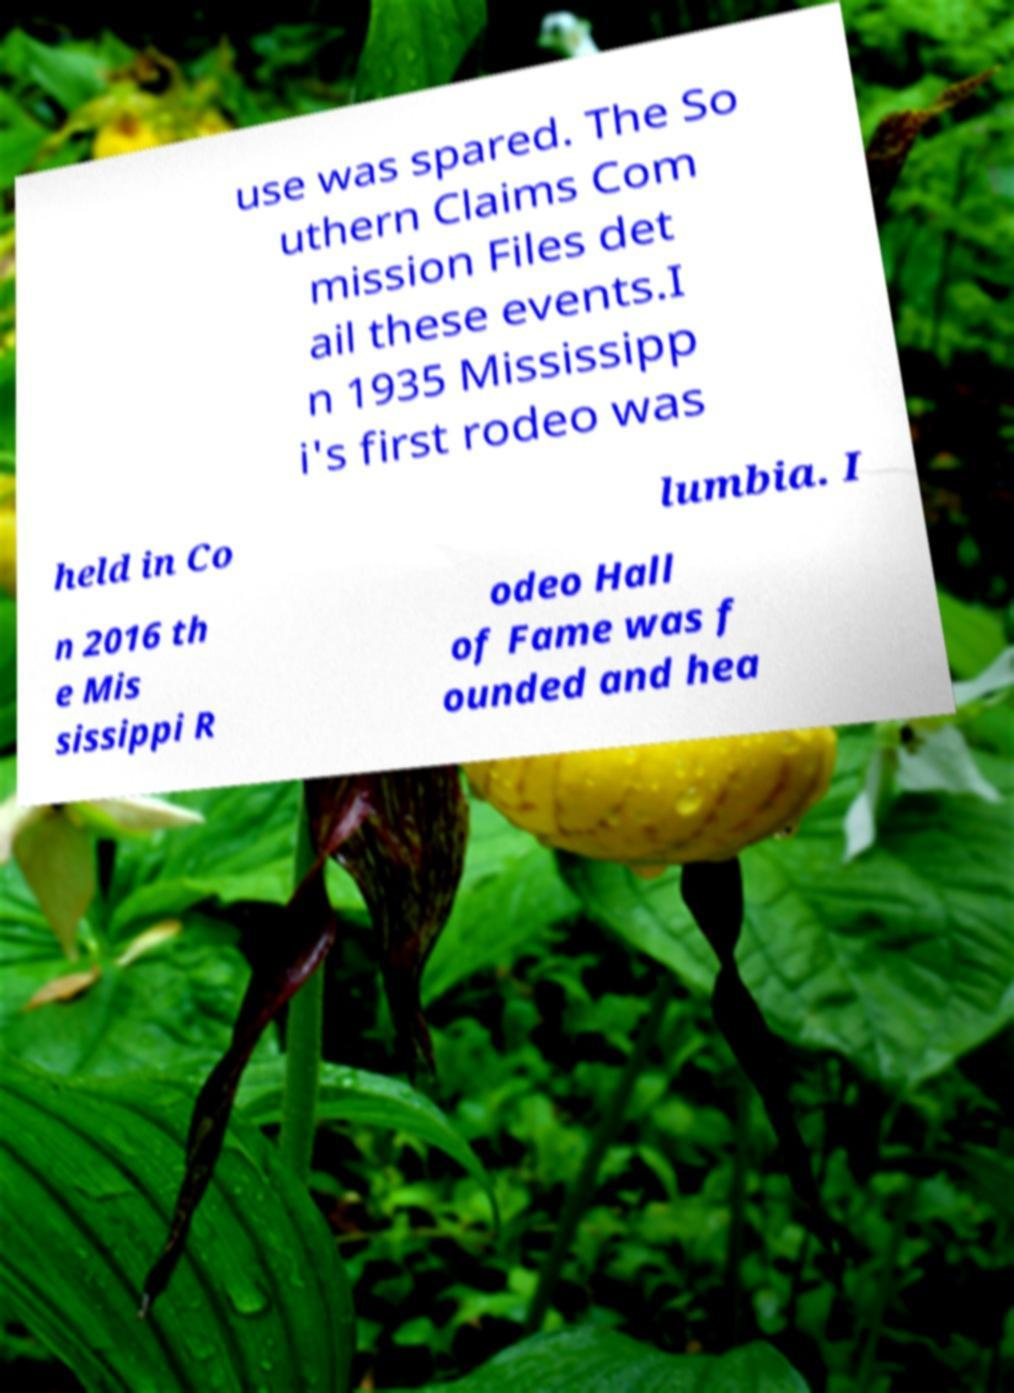What messages or text are displayed in this image? I need them in a readable, typed format. use was spared. The So uthern Claims Com mission Files det ail these events.I n 1935 Mississipp i's first rodeo was held in Co lumbia. I n 2016 th e Mis sissippi R odeo Hall of Fame was f ounded and hea 